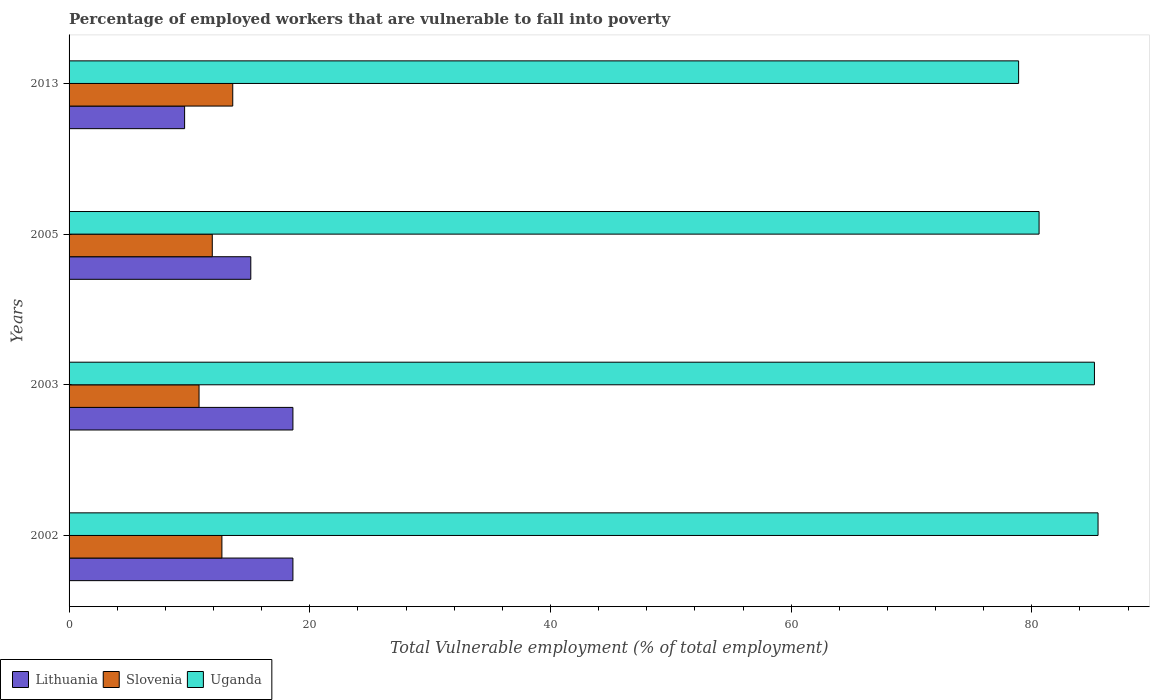How many different coloured bars are there?
Give a very brief answer. 3. How many groups of bars are there?
Your answer should be very brief. 4. Are the number of bars per tick equal to the number of legend labels?
Provide a succinct answer. Yes. How many bars are there on the 1st tick from the top?
Offer a terse response. 3. In how many cases, is the number of bars for a given year not equal to the number of legend labels?
Your response must be concise. 0. What is the percentage of employed workers who are vulnerable to fall into poverty in Slovenia in 2002?
Your answer should be very brief. 12.7. Across all years, what is the maximum percentage of employed workers who are vulnerable to fall into poverty in Lithuania?
Your answer should be very brief. 18.6. Across all years, what is the minimum percentage of employed workers who are vulnerable to fall into poverty in Slovenia?
Keep it short and to the point. 10.8. What is the total percentage of employed workers who are vulnerable to fall into poverty in Uganda in the graph?
Keep it short and to the point. 330.2. What is the difference between the percentage of employed workers who are vulnerable to fall into poverty in Uganda in 2005 and that in 2013?
Keep it short and to the point. 1.7. What is the difference between the percentage of employed workers who are vulnerable to fall into poverty in Uganda in 2003 and the percentage of employed workers who are vulnerable to fall into poverty in Lithuania in 2002?
Offer a terse response. 66.6. What is the average percentage of employed workers who are vulnerable to fall into poverty in Uganda per year?
Ensure brevity in your answer.  82.55. In the year 2002, what is the difference between the percentage of employed workers who are vulnerable to fall into poverty in Slovenia and percentage of employed workers who are vulnerable to fall into poverty in Uganda?
Provide a short and direct response. -72.8. In how many years, is the percentage of employed workers who are vulnerable to fall into poverty in Lithuania greater than 60 %?
Give a very brief answer. 0. What is the ratio of the percentage of employed workers who are vulnerable to fall into poverty in Lithuania in 2003 to that in 2005?
Keep it short and to the point. 1.23. Is the percentage of employed workers who are vulnerable to fall into poverty in Uganda in 2002 less than that in 2013?
Make the answer very short. No. Is the difference between the percentage of employed workers who are vulnerable to fall into poverty in Slovenia in 2002 and 2003 greater than the difference between the percentage of employed workers who are vulnerable to fall into poverty in Uganda in 2002 and 2003?
Ensure brevity in your answer.  Yes. What is the difference between the highest and the second highest percentage of employed workers who are vulnerable to fall into poverty in Slovenia?
Ensure brevity in your answer.  0.9. What is the difference between the highest and the lowest percentage of employed workers who are vulnerable to fall into poverty in Lithuania?
Offer a very short reply. 9. Is the sum of the percentage of employed workers who are vulnerable to fall into poverty in Uganda in 2002 and 2013 greater than the maximum percentage of employed workers who are vulnerable to fall into poverty in Lithuania across all years?
Your response must be concise. Yes. What does the 2nd bar from the top in 2013 represents?
Your answer should be compact. Slovenia. What does the 1st bar from the bottom in 2013 represents?
Ensure brevity in your answer.  Lithuania. Is it the case that in every year, the sum of the percentage of employed workers who are vulnerable to fall into poverty in Uganda and percentage of employed workers who are vulnerable to fall into poverty in Lithuania is greater than the percentage of employed workers who are vulnerable to fall into poverty in Slovenia?
Offer a terse response. Yes. How many years are there in the graph?
Provide a short and direct response. 4. Does the graph contain any zero values?
Your answer should be compact. No. How many legend labels are there?
Provide a short and direct response. 3. How are the legend labels stacked?
Provide a succinct answer. Horizontal. What is the title of the graph?
Offer a terse response. Percentage of employed workers that are vulnerable to fall into poverty. What is the label or title of the X-axis?
Your response must be concise. Total Vulnerable employment (% of total employment). What is the Total Vulnerable employment (% of total employment) of Lithuania in 2002?
Offer a terse response. 18.6. What is the Total Vulnerable employment (% of total employment) of Slovenia in 2002?
Provide a short and direct response. 12.7. What is the Total Vulnerable employment (% of total employment) in Uganda in 2002?
Offer a very short reply. 85.5. What is the Total Vulnerable employment (% of total employment) in Lithuania in 2003?
Offer a very short reply. 18.6. What is the Total Vulnerable employment (% of total employment) in Slovenia in 2003?
Ensure brevity in your answer.  10.8. What is the Total Vulnerable employment (% of total employment) of Uganda in 2003?
Your answer should be very brief. 85.2. What is the Total Vulnerable employment (% of total employment) of Lithuania in 2005?
Ensure brevity in your answer.  15.1. What is the Total Vulnerable employment (% of total employment) of Slovenia in 2005?
Provide a short and direct response. 11.9. What is the Total Vulnerable employment (% of total employment) in Uganda in 2005?
Your response must be concise. 80.6. What is the Total Vulnerable employment (% of total employment) of Lithuania in 2013?
Offer a terse response. 9.6. What is the Total Vulnerable employment (% of total employment) of Slovenia in 2013?
Offer a very short reply. 13.6. What is the Total Vulnerable employment (% of total employment) in Uganda in 2013?
Provide a succinct answer. 78.9. Across all years, what is the maximum Total Vulnerable employment (% of total employment) of Lithuania?
Offer a terse response. 18.6. Across all years, what is the maximum Total Vulnerable employment (% of total employment) of Slovenia?
Keep it short and to the point. 13.6. Across all years, what is the maximum Total Vulnerable employment (% of total employment) of Uganda?
Provide a short and direct response. 85.5. Across all years, what is the minimum Total Vulnerable employment (% of total employment) of Lithuania?
Make the answer very short. 9.6. Across all years, what is the minimum Total Vulnerable employment (% of total employment) in Slovenia?
Offer a terse response. 10.8. Across all years, what is the minimum Total Vulnerable employment (% of total employment) in Uganda?
Ensure brevity in your answer.  78.9. What is the total Total Vulnerable employment (% of total employment) in Lithuania in the graph?
Your answer should be compact. 61.9. What is the total Total Vulnerable employment (% of total employment) of Uganda in the graph?
Your response must be concise. 330.2. What is the difference between the Total Vulnerable employment (% of total employment) of Lithuania in 2002 and that in 2003?
Your answer should be very brief. 0. What is the difference between the Total Vulnerable employment (% of total employment) in Slovenia in 2002 and that in 2003?
Ensure brevity in your answer.  1.9. What is the difference between the Total Vulnerable employment (% of total employment) in Uganda in 2002 and that in 2003?
Your answer should be compact. 0.3. What is the difference between the Total Vulnerable employment (% of total employment) of Lithuania in 2002 and that in 2005?
Ensure brevity in your answer.  3.5. What is the difference between the Total Vulnerable employment (% of total employment) in Slovenia in 2002 and that in 2005?
Your answer should be very brief. 0.8. What is the difference between the Total Vulnerable employment (% of total employment) of Uganda in 2002 and that in 2005?
Provide a short and direct response. 4.9. What is the difference between the Total Vulnerable employment (% of total employment) in Lithuania in 2002 and that in 2013?
Provide a succinct answer. 9. What is the difference between the Total Vulnerable employment (% of total employment) of Slovenia in 2002 and that in 2013?
Offer a terse response. -0.9. What is the difference between the Total Vulnerable employment (% of total employment) in Uganda in 2002 and that in 2013?
Your response must be concise. 6.6. What is the difference between the Total Vulnerable employment (% of total employment) in Slovenia in 2003 and that in 2005?
Provide a short and direct response. -1.1. What is the difference between the Total Vulnerable employment (% of total employment) in Uganda in 2003 and that in 2005?
Provide a succinct answer. 4.6. What is the difference between the Total Vulnerable employment (% of total employment) of Slovenia in 2003 and that in 2013?
Make the answer very short. -2.8. What is the difference between the Total Vulnerable employment (% of total employment) of Uganda in 2003 and that in 2013?
Give a very brief answer. 6.3. What is the difference between the Total Vulnerable employment (% of total employment) of Lithuania in 2005 and that in 2013?
Provide a succinct answer. 5.5. What is the difference between the Total Vulnerable employment (% of total employment) of Uganda in 2005 and that in 2013?
Ensure brevity in your answer.  1.7. What is the difference between the Total Vulnerable employment (% of total employment) of Lithuania in 2002 and the Total Vulnerable employment (% of total employment) of Uganda in 2003?
Make the answer very short. -66.6. What is the difference between the Total Vulnerable employment (% of total employment) of Slovenia in 2002 and the Total Vulnerable employment (% of total employment) of Uganda in 2003?
Offer a terse response. -72.5. What is the difference between the Total Vulnerable employment (% of total employment) of Lithuania in 2002 and the Total Vulnerable employment (% of total employment) of Uganda in 2005?
Ensure brevity in your answer.  -62. What is the difference between the Total Vulnerable employment (% of total employment) of Slovenia in 2002 and the Total Vulnerable employment (% of total employment) of Uganda in 2005?
Your answer should be very brief. -67.9. What is the difference between the Total Vulnerable employment (% of total employment) in Lithuania in 2002 and the Total Vulnerable employment (% of total employment) in Uganda in 2013?
Provide a short and direct response. -60.3. What is the difference between the Total Vulnerable employment (% of total employment) of Slovenia in 2002 and the Total Vulnerable employment (% of total employment) of Uganda in 2013?
Give a very brief answer. -66.2. What is the difference between the Total Vulnerable employment (% of total employment) in Lithuania in 2003 and the Total Vulnerable employment (% of total employment) in Uganda in 2005?
Provide a succinct answer. -62. What is the difference between the Total Vulnerable employment (% of total employment) of Slovenia in 2003 and the Total Vulnerable employment (% of total employment) of Uganda in 2005?
Offer a very short reply. -69.8. What is the difference between the Total Vulnerable employment (% of total employment) of Lithuania in 2003 and the Total Vulnerable employment (% of total employment) of Slovenia in 2013?
Give a very brief answer. 5. What is the difference between the Total Vulnerable employment (% of total employment) of Lithuania in 2003 and the Total Vulnerable employment (% of total employment) of Uganda in 2013?
Offer a terse response. -60.3. What is the difference between the Total Vulnerable employment (% of total employment) in Slovenia in 2003 and the Total Vulnerable employment (% of total employment) in Uganda in 2013?
Offer a very short reply. -68.1. What is the difference between the Total Vulnerable employment (% of total employment) of Lithuania in 2005 and the Total Vulnerable employment (% of total employment) of Slovenia in 2013?
Provide a succinct answer. 1.5. What is the difference between the Total Vulnerable employment (% of total employment) of Lithuania in 2005 and the Total Vulnerable employment (% of total employment) of Uganda in 2013?
Give a very brief answer. -63.8. What is the difference between the Total Vulnerable employment (% of total employment) in Slovenia in 2005 and the Total Vulnerable employment (% of total employment) in Uganda in 2013?
Offer a very short reply. -67. What is the average Total Vulnerable employment (% of total employment) in Lithuania per year?
Offer a very short reply. 15.47. What is the average Total Vulnerable employment (% of total employment) in Slovenia per year?
Offer a very short reply. 12.25. What is the average Total Vulnerable employment (% of total employment) in Uganda per year?
Your answer should be compact. 82.55. In the year 2002, what is the difference between the Total Vulnerable employment (% of total employment) in Lithuania and Total Vulnerable employment (% of total employment) in Uganda?
Provide a short and direct response. -66.9. In the year 2002, what is the difference between the Total Vulnerable employment (% of total employment) of Slovenia and Total Vulnerable employment (% of total employment) of Uganda?
Offer a terse response. -72.8. In the year 2003, what is the difference between the Total Vulnerable employment (% of total employment) of Lithuania and Total Vulnerable employment (% of total employment) of Slovenia?
Give a very brief answer. 7.8. In the year 2003, what is the difference between the Total Vulnerable employment (% of total employment) in Lithuania and Total Vulnerable employment (% of total employment) in Uganda?
Your answer should be compact. -66.6. In the year 2003, what is the difference between the Total Vulnerable employment (% of total employment) in Slovenia and Total Vulnerable employment (% of total employment) in Uganda?
Your answer should be very brief. -74.4. In the year 2005, what is the difference between the Total Vulnerable employment (% of total employment) of Lithuania and Total Vulnerable employment (% of total employment) of Uganda?
Keep it short and to the point. -65.5. In the year 2005, what is the difference between the Total Vulnerable employment (% of total employment) in Slovenia and Total Vulnerable employment (% of total employment) in Uganda?
Your response must be concise. -68.7. In the year 2013, what is the difference between the Total Vulnerable employment (% of total employment) in Lithuania and Total Vulnerable employment (% of total employment) in Slovenia?
Keep it short and to the point. -4. In the year 2013, what is the difference between the Total Vulnerable employment (% of total employment) of Lithuania and Total Vulnerable employment (% of total employment) of Uganda?
Your answer should be very brief. -69.3. In the year 2013, what is the difference between the Total Vulnerable employment (% of total employment) of Slovenia and Total Vulnerable employment (% of total employment) of Uganda?
Give a very brief answer. -65.3. What is the ratio of the Total Vulnerable employment (% of total employment) in Lithuania in 2002 to that in 2003?
Keep it short and to the point. 1. What is the ratio of the Total Vulnerable employment (% of total employment) of Slovenia in 2002 to that in 2003?
Ensure brevity in your answer.  1.18. What is the ratio of the Total Vulnerable employment (% of total employment) of Lithuania in 2002 to that in 2005?
Provide a succinct answer. 1.23. What is the ratio of the Total Vulnerable employment (% of total employment) in Slovenia in 2002 to that in 2005?
Make the answer very short. 1.07. What is the ratio of the Total Vulnerable employment (% of total employment) in Uganda in 2002 to that in 2005?
Keep it short and to the point. 1.06. What is the ratio of the Total Vulnerable employment (% of total employment) in Lithuania in 2002 to that in 2013?
Make the answer very short. 1.94. What is the ratio of the Total Vulnerable employment (% of total employment) in Slovenia in 2002 to that in 2013?
Provide a succinct answer. 0.93. What is the ratio of the Total Vulnerable employment (% of total employment) in Uganda in 2002 to that in 2013?
Offer a very short reply. 1.08. What is the ratio of the Total Vulnerable employment (% of total employment) in Lithuania in 2003 to that in 2005?
Keep it short and to the point. 1.23. What is the ratio of the Total Vulnerable employment (% of total employment) of Slovenia in 2003 to that in 2005?
Your response must be concise. 0.91. What is the ratio of the Total Vulnerable employment (% of total employment) in Uganda in 2003 to that in 2005?
Your response must be concise. 1.06. What is the ratio of the Total Vulnerable employment (% of total employment) in Lithuania in 2003 to that in 2013?
Your response must be concise. 1.94. What is the ratio of the Total Vulnerable employment (% of total employment) of Slovenia in 2003 to that in 2013?
Offer a very short reply. 0.79. What is the ratio of the Total Vulnerable employment (% of total employment) of Uganda in 2003 to that in 2013?
Make the answer very short. 1.08. What is the ratio of the Total Vulnerable employment (% of total employment) of Lithuania in 2005 to that in 2013?
Your response must be concise. 1.57. What is the ratio of the Total Vulnerable employment (% of total employment) of Slovenia in 2005 to that in 2013?
Offer a very short reply. 0.88. What is the ratio of the Total Vulnerable employment (% of total employment) of Uganda in 2005 to that in 2013?
Make the answer very short. 1.02. What is the difference between the highest and the second highest Total Vulnerable employment (% of total employment) of Lithuania?
Provide a succinct answer. 0. What is the difference between the highest and the second highest Total Vulnerable employment (% of total employment) of Slovenia?
Your answer should be compact. 0.9. What is the difference between the highest and the second highest Total Vulnerable employment (% of total employment) in Uganda?
Provide a succinct answer. 0.3. What is the difference between the highest and the lowest Total Vulnerable employment (% of total employment) of Lithuania?
Your response must be concise. 9. What is the difference between the highest and the lowest Total Vulnerable employment (% of total employment) in Slovenia?
Keep it short and to the point. 2.8. 